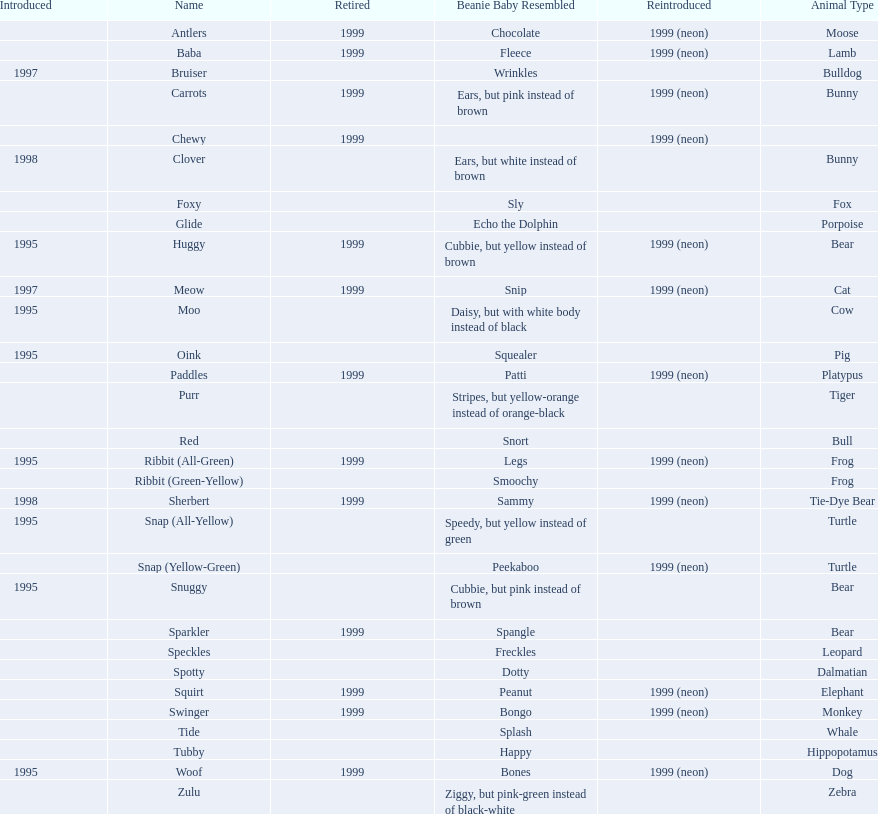Parse the table in full. {'header': ['Introduced', 'Name', 'Retired', 'Beanie Baby Resembled', 'Reintroduced', 'Animal Type'], 'rows': [['', 'Antlers', '1999', 'Chocolate', '1999 (neon)', 'Moose'], ['', 'Baba', '1999', 'Fleece', '1999 (neon)', 'Lamb'], ['1997', 'Bruiser', '', 'Wrinkles', '', 'Bulldog'], ['', 'Carrots', '1999', 'Ears, but pink instead of brown', '1999 (neon)', 'Bunny'], ['', 'Chewy', '1999', '', '1999 (neon)', ''], ['1998', 'Clover', '', 'Ears, but white instead of brown', '', 'Bunny'], ['', 'Foxy', '', 'Sly', '', 'Fox'], ['', 'Glide', '', 'Echo the Dolphin', '', 'Porpoise'], ['1995', 'Huggy', '1999', 'Cubbie, but yellow instead of brown', '1999 (neon)', 'Bear'], ['1997', 'Meow', '1999', 'Snip', '1999 (neon)', 'Cat'], ['1995', 'Moo', '', 'Daisy, but with white body instead of black', '', 'Cow'], ['1995', 'Oink', '', 'Squealer', '', 'Pig'], ['', 'Paddles', '1999', 'Patti', '1999 (neon)', 'Platypus'], ['', 'Purr', '', 'Stripes, but yellow-orange instead of orange-black', '', 'Tiger'], ['', 'Red', '', 'Snort', '', 'Bull'], ['1995', 'Ribbit (All-Green)', '1999', 'Legs', '1999 (neon)', 'Frog'], ['', 'Ribbit (Green-Yellow)', '', 'Smoochy', '', 'Frog'], ['1998', 'Sherbert', '1999', 'Sammy', '1999 (neon)', 'Tie-Dye Bear'], ['1995', 'Snap (All-Yellow)', '', 'Speedy, but yellow instead of green', '', 'Turtle'], ['', 'Snap (Yellow-Green)', '', 'Peekaboo', '1999 (neon)', 'Turtle'], ['1995', 'Snuggy', '', 'Cubbie, but pink instead of brown', '', 'Bear'], ['', 'Sparkler', '1999', 'Spangle', '', 'Bear'], ['', 'Speckles', '', 'Freckles', '', 'Leopard'], ['', 'Spotty', '', 'Dotty', '', 'Dalmatian'], ['', 'Squirt', '1999', 'Peanut', '1999 (neon)', 'Elephant'], ['', 'Swinger', '1999', 'Bongo', '1999 (neon)', 'Monkey'], ['', 'Tide', '', 'Splash', '', 'Whale'], ['', 'Tubby', '', 'Happy', '', 'Hippopotamus'], ['1995', 'Woof', '1999', 'Bones', '1999 (neon)', 'Dog'], ['', 'Zulu', '', 'Ziggy, but pink-green instead of black-white', '', 'Zebra']]} Which is the only pillow pal without a listed animal type? Chewy. 